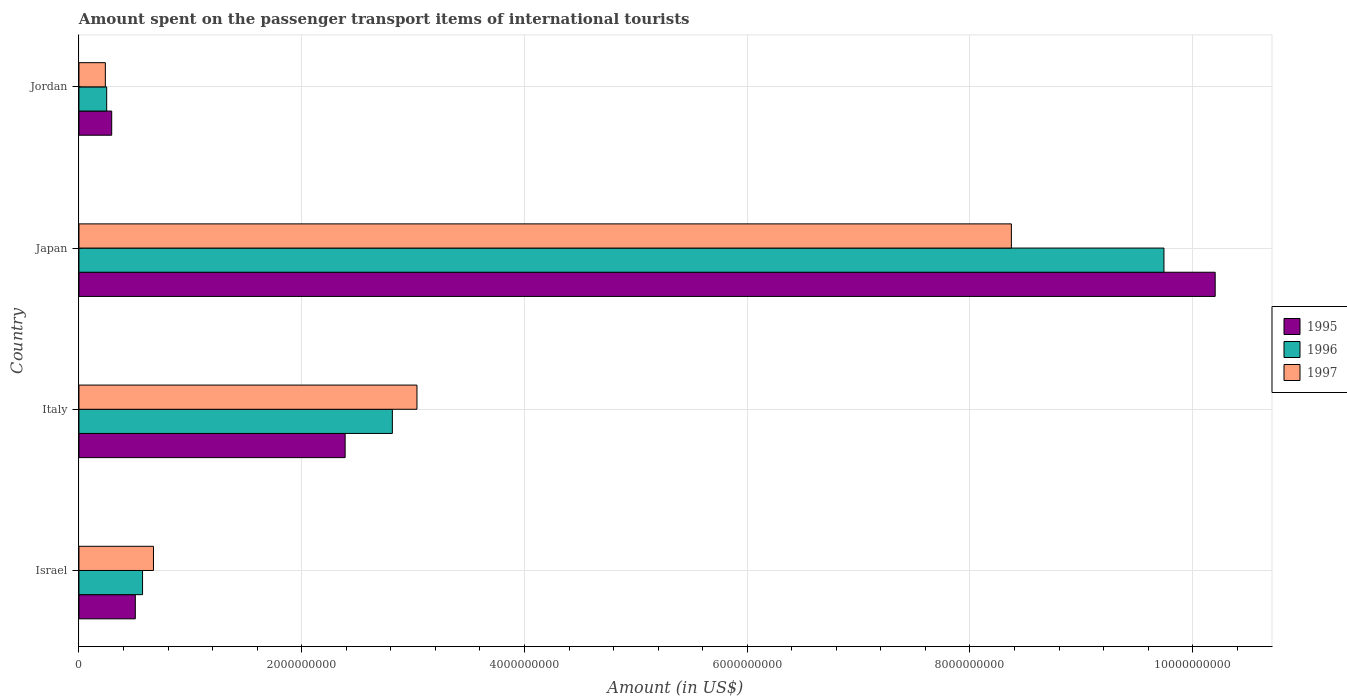How many different coloured bars are there?
Make the answer very short. 3. How many groups of bars are there?
Keep it short and to the point. 4. Are the number of bars per tick equal to the number of legend labels?
Your answer should be very brief. Yes. How many bars are there on the 4th tick from the top?
Offer a very short reply. 3. How many bars are there on the 1st tick from the bottom?
Your answer should be very brief. 3. What is the label of the 1st group of bars from the top?
Offer a very short reply. Jordan. What is the amount spent on the passenger transport items of international tourists in 1995 in Italy?
Ensure brevity in your answer.  2.39e+09. Across all countries, what is the maximum amount spent on the passenger transport items of international tourists in 1996?
Offer a terse response. 9.74e+09. Across all countries, what is the minimum amount spent on the passenger transport items of international tourists in 1996?
Give a very brief answer. 2.49e+08. In which country was the amount spent on the passenger transport items of international tourists in 1996 maximum?
Make the answer very short. Japan. In which country was the amount spent on the passenger transport items of international tourists in 1995 minimum?
Provide a succinct answer. Jordan. What is the total amount spent on the passenger transport items of international tourists in 1997 in the graph?
Give a very brief answer. 1.23e+1. What is the difference between the amount spent on the passenger transport items of international tourists in 1996 in Israel and that in Italy?
Provide a succinct answer. -2.24e+09. What is the difference between the amount spent on the passenger transport items of international tourists in 1997 in Italy and the amount spent on the passenger transport items of international tourists in 1996 in Jordan?
Your response must be concise. 2.79e+09. What is the average amount spent on the passenger transport items of international tourists in 1995 per country?
Offer a terse response. 3.35e+09. What is the difference between the amount spent on the passenger transport items of international tourists in 1997 and amount spent on the passenger transport items of international tourists in 1995 in Japan?
Provide a succinct answer. -1.83e+09. What is the ratio of the amount spent on the passenger transport items of international tourists in 1997 in Japan to that in Jordan?
Your answer should be compact. 35.32. Is the amount spent on the passenger transport items of international tourists in 1995 in Japan less than that in Jordan?
Your answer should be very brief. No. Is the difference between the amount spent on the passenger transport items of international tourists in 1997 in Israel and Jordan greater than the difference between the amount spent on the passenger transport items of international tourists in 1995 in Israel and Jordan?
Your response must be concise. Yes. What is the difference between the highest and the second highest amount spent on the passenger transport items of international tourists in 1996?
Give a very brief answer. 6.93e+09. What is the difference between the highest and the lowest amount spent on the passenger transport items of international tourists in 1996?
Provide a short and direct response. 9.49e+09. In how many countries, is the amount spent on the passenger transport items of international tourists in 1996 greater than the average amount spent on the passenger transport items of international tourists in 1996 taken over all countries?
Ensure brevity in your answer.  1. Is the sum of the amount spent on the passenger transport items of international tourists in 1997 in Italy and Jordan greater than the maximum amount spent on the passenger transport items of international tourists in 1996 across all countries?
Ensure brevity in your answer.  No. What does the 1st bar from the bottom in Italy represents?
Keep it short and to the point. 1995. Is it the case that in every country, the sum of the amount spent on the passenger transport items of international tourists in 1996 and amount spent on the passenger transport items of international tourists in 1995 is greater than the amount spent on the passenger transport items of international tourists in 1997?
Provide a short and direct response. Yes. Are all the bars in the graph horizontal?
Your answer should be compact. Yes. What is the difference between two consecutive major ticks on the X-axis?
Make the answer very short. 2.00e+09. Are the values on the major ticks of X-axis written in scientific E-notation?
Your response must be concise. No. Does the graph contain any zero values?
Give a very brief answer. No. Does the graph contain grids?
Offer a terse response. Yes. How many legend labels are there?
Your answer should be very brief. 3. How are the legend labels stacked?
Your response must be concise. Vertical. What is the title of the graph?
Your answer should be very brief. Amount spent on the passenger transport items of international tourists. What is the label or title of the Y-axis?
Provide a succinct answer. Country. What is the Amount (in US$) in 1995 in Israel?
Your response must be concise. 5.06e+08. What is the Amount (in US$) in 1996 in Israel?
Offer a terse response. 5.71e+08. What is the Amount (in US$) of 1997 in Israel?
Your answer should be compact. 6.69e+08. What is the Amount (in US$) in 1995 in Italy?
Your answer should be very brief. 2.39e+09. What is the Amount (in US$) in 1996 in Italy?
Offer a terse response. 2.81e+09. What is the Amount (in US$) in 1997 in Italy?
Give a very brief answer. 3.04e+09. What is the Amount (in US$) in 1995 in Japan?
Offer a very short reply. 1.02e+1. What is the Amount (in US$) in 1996 in Japan?
Offer a very short reply. 9.74e+09. What is the Amount (in US$) of 1997 in Japan?
Your response must be concise. 8.37e+09. What is the Amount (in US$) in 1995 in Jordan?
Your answer should be very brief. 2.94e+08. What is the Amount (in US$) in 1996 in Jordan?
Keep it short and to the point. 2.49e+08. What is the Amount (in US$) of 1997 in Jordan?
Your response must be concise. 2.37e+08. Across all countries, what is the maximum Amount (in US$) in 1995?
Ensure brevity in your answer.  1.02e+1. Across all countries, what is the maximum Amount (in US$) of 1996?
Provide a succinct answer. 9.74e+09. Across all countries, what is the maximum Amount (in US$) of 1997?
Your answer should be very brief. 8.37e+09. Across all countries, what is the minimum Amount (in US$) of 1995?
Offer a terse response. 2.94e+08. Across all countries, what is the minimum Amount (in US$) of 1996?
Give a very brief answer. 2.49e+08. Across all countries, what is the minimum Amount (in US$) in 1997?
Provide a succinct answer. 2.37e+08. What is the total Amount (in US$) in 1995 in the graph?
Offer a very short reply. 1.34e+1. What is the total Amount (in US$) in 1996 in the graph?
Ensure brevity in your answer.  1.34e+1. What is the total Amount (in US$) in 1997 in the graph?
Your answer should be very brief. 1.23e+1. What is the difference between the Amount (in US$) of 1995 in Israel and that in Italy?
Offer a very short reply. -1.88e+09. What is the difference between the Amount (in US$) in 1996 in Israel and that in Italy?
Provide a succinct answer. -2.24e+09. What is the difference between the Amount (in US$) of 1997 in Israel and that in Italy?
Provide a succinct answer. -2.37e+09. What is the difference between the Amount (in US$) of 1995 in Israel and that in Japan?
Give a very brief answer. -9.70e+09. What is the difference between the Amount (in US$) in 1996 in Israel and that in Japan?
Give a very brief answer. -9.17e+09. What is the difference between the Amount (in US$) in 1997 in Israel and that in Japan?
Give a very brief answer. -7.70e+09. What is the difference between the Amount (in US$) of 1995 in Israel and that in Jordan?
Ensure brevity in your answer.  2.12e+08. What is the difference between the Amount (in US$) in 1996 in Israel and that in Jordan?
Ensure brevity in your answer.  3.22e+08. What is the difference between the Amount (in US$) of 1997 in Israel and that in Jordan?
Give a very brief answer. 4.32e+08. What is the difference between the Amount (in US$) of 1995 in Italy and that in Japan?
Provide a succinct answer. -7.81e+09. What is the difference between the Amount (in US$) of 1996 in Italy and that in Japan?
Make the answer very short. -6.93e+09. What is the difference between the Amount (in US$) of 1997 in Italy and that in Japan?
Ensure brevity in your answer.  -5.34e+09. What is the difference between the Amount (in US$) in 1995 in Italy and that in Jordan?
Your answer should be very brief. 2.10e+09. What is the difference between the Amount (in US$) of 1996 in Italy and that in Jordan?
Make the answer very short. 2.56e+09. What is the difference between the Amount (in US$) in 1997 in Italy and that in Jordan?
Keep it short and to the point. 2.80e+09. What is the difference between the Amount (in US$) in 1995 in Japan and that in Jordan?
Make the answer very short. 9.91e+09. What is the difference between the Amount (in US$) of 1996 in Japan and that in Jordan?
Ensure brevity in your answer.  9.49e+09. What is the difference between the Amount (in US$) of 1997 in Japan and that in Jordan?
Your answer should be very brief. 8.14e+09. What is the difference between the Amount (in US$) in 1995 in Israel and the Amount (in US$) in 1996 in Italy?
Provide a succinct answer. -2.31e+09. What is the difference between the Amount (in US$) of 1995 in Israel and the Amount (in US$) of 1997 in Italy?
Offer a terse response. -2.53e+09. What is the difference between the Amount (in US$) in 1996 in Israel and the Amount (in US$) in 1997 in Italy?
Keep it short and to the point. -2.46e+09. What is the difference between the Amount (in US$) of 1995 in Israel and the Amount (in US$) of 1996 in Japan?
Offer a terse response. -9.24e+09. What is the difference between the Amount (in US$) of 1995 in Israel and the Amount (in US$) of 1997 in Japan?
Your answer should be compact. -7.87e+09. What is the difference between the Amount (in US$) of 1996 in Israel and the Amount (in US$) of 1997 in Japan?
Keep it short and to the point. -7.80e+09. What is the difference between the Amount (in US$) of 1995 in Israel and the Amount (in US$) of 1996 in Jordan?
Ensure brevity in your answer.  2.57e+08. What is the difference between the Amount (in US$) in 1995 in Israel and the Amount (in US$) in 1997 in Jordan?
Ensure brevity in your answer.  2.69e+08. What is the difference between the Amount (in US$) in 1996 in Israel and the Amount (in US$) in 1997 in Jordan?
Your answer should be compact. 3.34e+08. What is the difference between the Amount (in US$) in 1995 in Italy and the Amount (in US$) in 1996 in Japan?
Keep it short and to the point. -7.35e+09. What is the difference between the Amount (in US$) of 1995 in Italy and the Amount (in US$) of 1997 in Japan?
Offer a very short reply. -5.98e+09. What is the difference between the Amount (in US$) in 1996 in Italy and the Amount (in US$) in 1997 in Japan?
Make the answer very short. -5.56e+09. What is the difference between the Amount (in US$) in 1995 in Italy and the Amount (in US$) in 1996 in Jordan?
Make the answer very short. 2.14e+09. What is the difference between the Amount (in US$) in 1995 in Italy and the Amount (in US$) in 1997 in Jordan?
Your response must be concise. 2.15e+09. What is the difference between the Amount (in US$) of 1996 in Italy and the Amount (in US$) of 1997 in Jordan?
Your response must be concise. 2.58e+09. What is the difference between the Amount (in US$) in 1995 in Japan and the Amount (in US$) in 1996 in Jordan?
Provide a short and direct response. 9.95e+09. What is the difference between the Amount (in US$) of 1995 in Japan and the Amount (in US$) of 1997 in Jordan?
Your response must be concise. 9.96e+09. What is the difference between the Amount (in US$) of 1996 in Japan and the Amount (in US$) of 1997 in Jordan?
Offer a terse response. 9.50e+09. What is the average Amount (in US$) of 1995 per country?
Offer a terse response. 3.35e+09. What is the average Amount (in US$) of 1996 per country?
Provide a succinct answer. 3.34e+09. What is the average Amount (in US$) of 1997 per country?
Your answer should be very brief. 3.08e+09. What is the difference between the Amount (in US$) of 1995 and Amount (in US$) of 1996 in Israel?
Keep it short and to the point. -6.50e+07. What is the difference between the Amount (in US$) of 1995 and Amount (in US$) of 1997 in Israel?
Your answer should be very brief. -1.63e+08. What is the difference between the Amount (in US$) of 1996 and Amount (in US$) of 1997 in Israel?
Provide a succinct answer. -9.80e+07. What is the difference between the Amount (in US$) of 1995 and Amount (in US$) of 1996 in Italy?
Provide a short and direct response. -4.24e+08. What is the difference between the Amount (in US$) in 1995 and Amount (in US$) in 1997 in Italy?
Ensure brevity in your answer.  -6.45e+08. What is the difference between the Amount (in US$) of 1996 and Amount (in US$) of 1997 in Italy?
Your response must be concise. -2.21e+08. What is the difference between the Amount (in US$) in 1995 and Amount (in US$) in 1996 in Japan?
Your answer should be very brief. 4.60e+08. What is the difference between the Amount (in US$) in 1995 and Amount (in US$) in 1997 in Japan?
Offer a terse response. 1.83e+09. What is the difference between the Amount (in US$) of 1996 and Amount (in US$) of 1997 in Japan?
Your response must be concise. 1.37e+09. What is the difference between the Amount (in US$) of 1995 and Amount (in US$) of 1996 in Jordan?
Offer a very short reply. 4.50e+07. What is the difference between the Amount (in US$) in 1995 and Amount (in US$) in 1997 in Jordan?
Your response must be concise. 5.70e+07. What is the ratio of the Amount (in US$) of 1995 in Israel to that in Italy?
Your response must be concise. 0.21. What is the ratio of the Amount (in US$) of 1996 in Israel to that in Italy?
Offer a terse response. 0.2. What is the ratio of the Amount (in US$) in 1997 in Israel to that in Italy?
Give a very brief answer. 0.22. What is the ratio of the Amount (in US$) of 1995 in Israel to that in Japan?
Provide a short and direct response. 0.05. What is the ratio of the Amount (in US$) of 1996 in Israel to that in Japan?
Keep it short and to the point. 0.06. What is the ratio of the Amount (in US$) of 1997 in Israel to that in Japan?
Provide a short and direct response. 0.08. What is the ratio of the Amount (in US$) of 1995 in Israel to that in Jordan?
Offer a terse response. 1.72. What is the ratio of the Amount (in US$) in 1996 in Israel to that in Jordan?
Make the answer very short. 2.29. What is the ratio of the Amount (in US$) of 1997 in Israel to that in Jordan?
Your answer should be very brief. 2.82. What is the ratio of the Amount (in US$) in 1995 in Italy to that in Japan?
Ensure brevity in your answer.  0.23. What is the ratio of the Amount (in US$) in 1996 in Italy to that in Japan?
Offer a very short reply. 0.29. What is the ratio of the Amount (in US$) of 1997 in Italy to that in Japan?
Your response must be concise. 0.36. What is the ratio of the Amount (in US$) of 1995 in Italy to that in Jordan?
Offer a very short reply. 8.13. What is the ratio of the Amount (in US$) of 1996 in Italy to that in Jordan?
Offer a terse response. 11.3. What is the ratio of the Amount (in US$) in 1997 in Italy to that in Jordan?
Make the answer very short. 12.81. What is the ratio of the Amount (in US$) in 1995 in Japan to that in Jordan?
Offer a very short reply. 34.7. What is the ratio of the Amount (in US$) of 1996 in Japan to that in Jordan?
Provide a succinct answer. 39.12. What is the ratio of the Amount (in US$) in 1997 in Japan to that in Jordan?
Keep it short and to the point. 35.32. What is the difference between the highest and the second highest Amount (in US$) in 1995?
Offer a very short reply. 7.81e+09. What is the difference between the highest and the second highest Amount (in US$) of 1996?
Provide a short and direct response. 6.93e+09. What is the difference between the highest and the second highest Amount (in US$) of 1997?
Make the answer very short. 5.34e+09. What is the difference between the highest and the lowest Amount (in US$) in 1995?
Your answer should be very brief. 9.91e+09. What is the difference between the highest and the lowest Amount (in US$) of 1996?
Ensure brevity in your answer.  9.49e+09. What is the difference between the highest and the lowest Amount (in US$) of 1997?
Your response must be concise. 8.14e+09. 